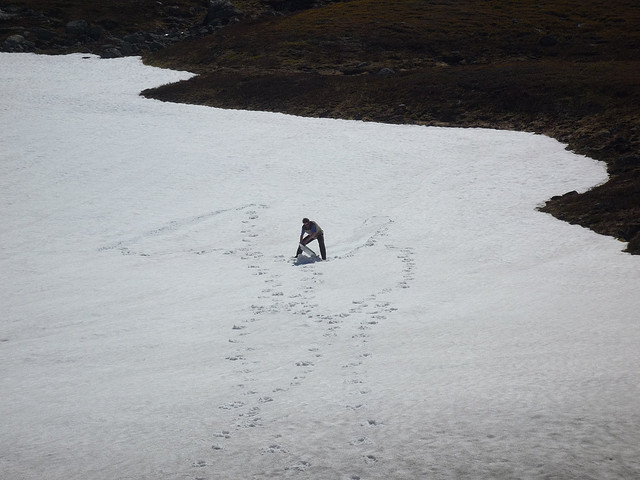<image>Which beach is this? It is unknown which beach this is. It could possibly be in Florida, Hawaii, Daytona, or even an Antarctic or white sand beach. Which beach is this? I don't know which beach it is. It can be in Florida, Hawaii, Daytona, or White Sand Beach. 